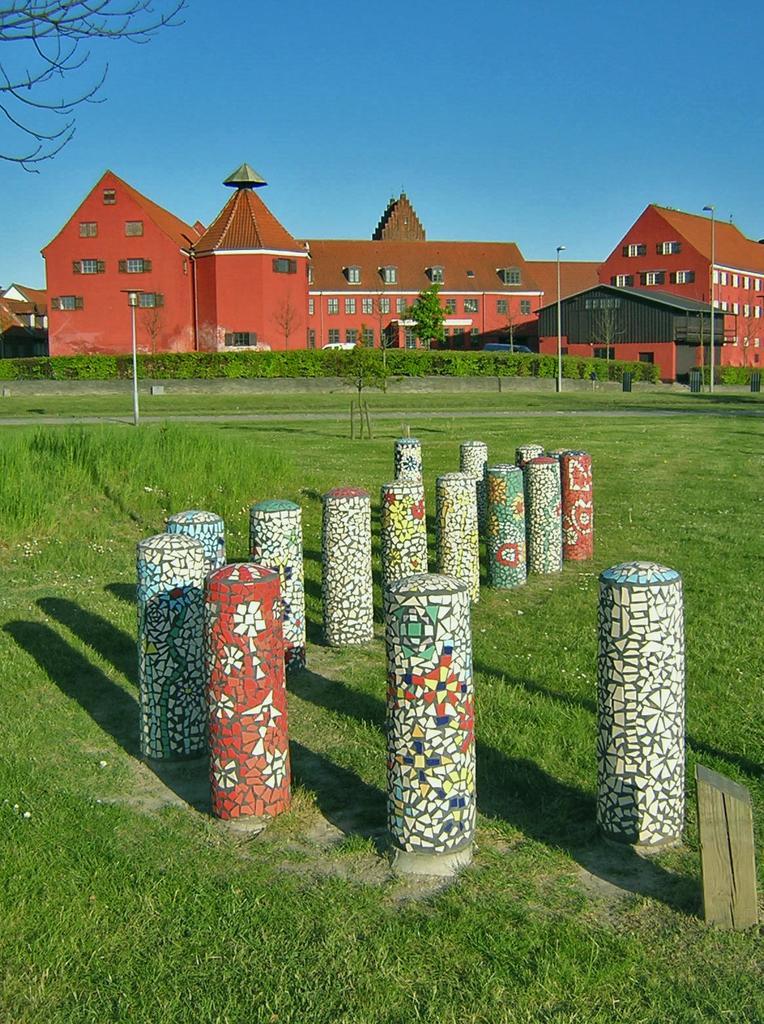In one or two sentences, can you explain what this image depicts? In this image there are few buildings, street lights, garden plants, grass, a tree, a pole, few black color objects and the sky. 